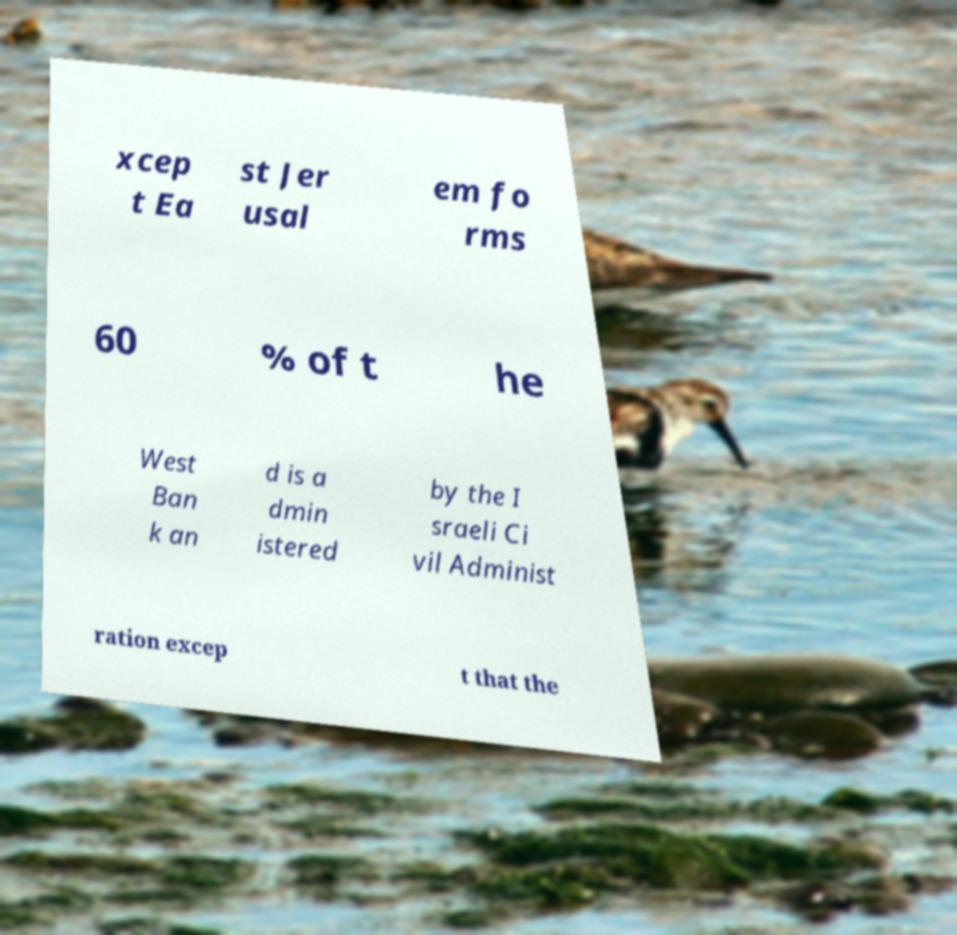There's text embedded in this image that I need extracted. Can you transcribe it verbatim? xcep t Ea st Jer usal em fo rms 60 % of t he West Ban k an d is a dmin istered by the I sraeli Ci vil Administ ration excep t that the 